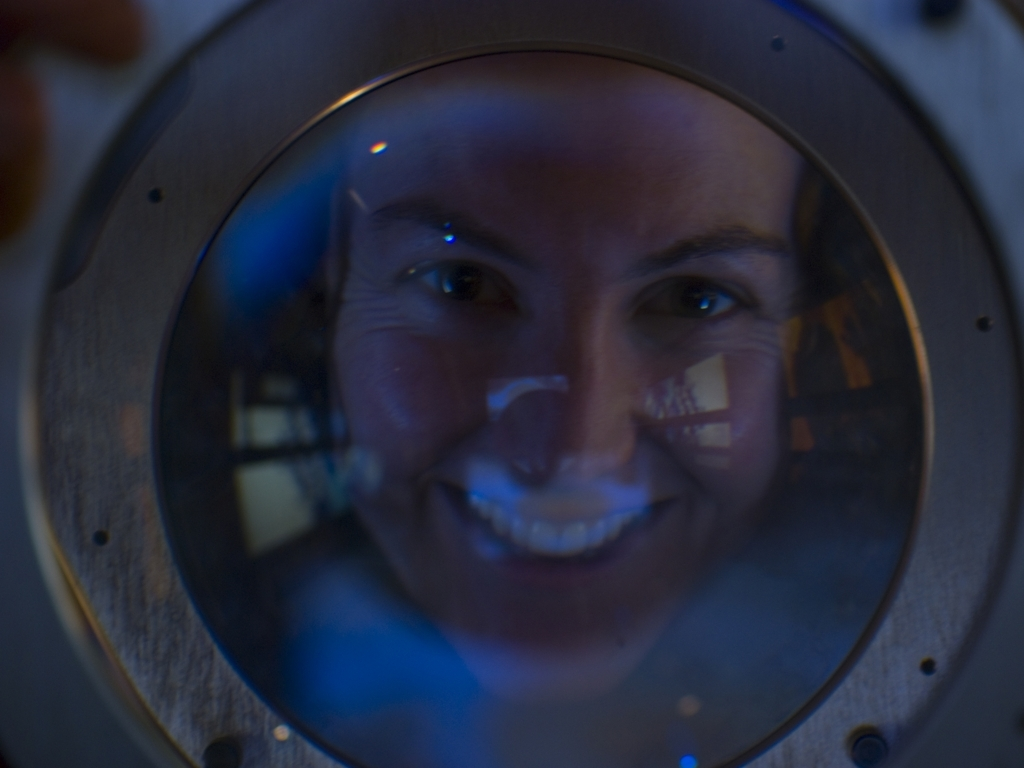What technical aspects could be improved in this photograph? Technically, this photograph might benefit from improved focus to enhance clarity and increased lighting to reveal more details of the subject's features. Additionally, adjusting the angle or the medium through which the photo is taken could minimize the distortive effects, unless these are intentional artistic choices. 